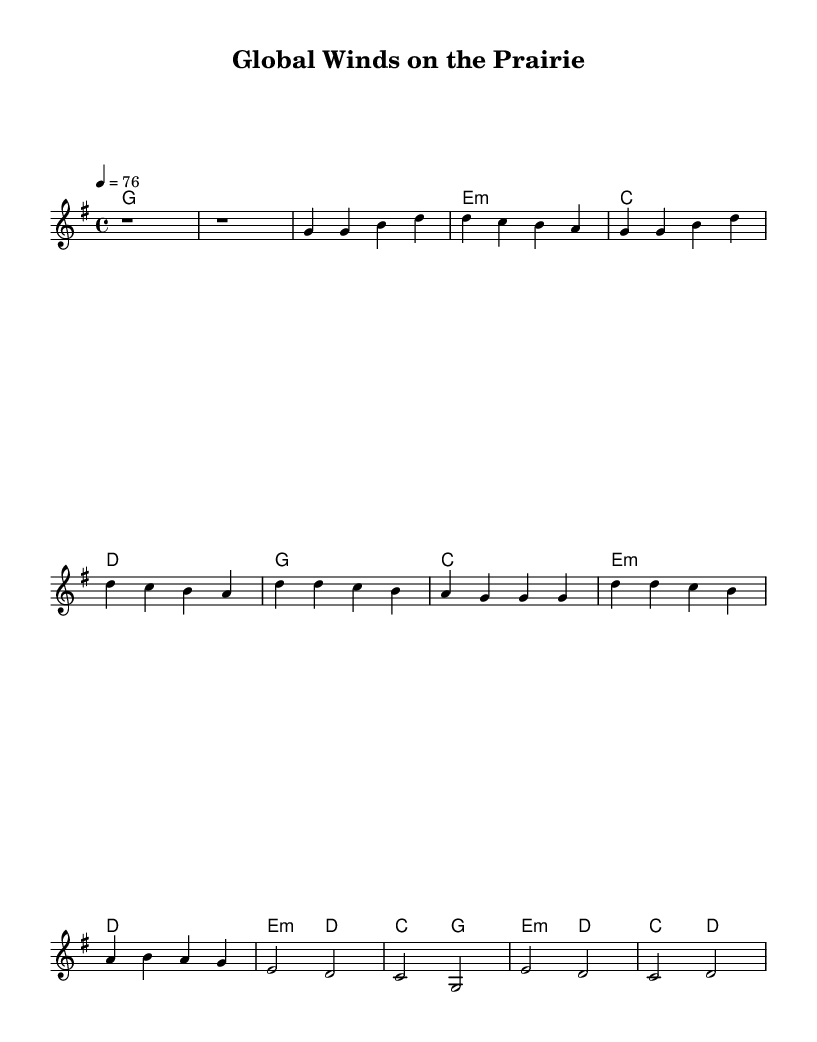What is the key signature of this music? The key signature indicates that the piece is in G major, which has one sharp. This can be identified from the beginning of the staff where the G major key signature is noted.
Answer: G major What is the time signature for this piece? The time signature is indicated at the beginning of the sheet music, showing four beats per measure. This is denoted by the "4/4" notation placed near the clef.
Answer: 4/4 What is the tempo marking for this song? The tempo marking is found at the beginning of the score, indicating how fast the piece should be played. In this case, it is set at 76 beats per minute.
Answer: 76 How many measures are there in the chorus section? By examining the chorus section, we can count the number of measures denoted by the bar lines. The chorus has four distinct measures.
Answer: 4 What type of chord follows the intro? The chord progression starts with a G major chord after the intro, which is evident from the chord names provided above the melody.
Answer: G major Why does the bridge use different chords compared to the verses? The bridge introduces new harmonic material, indicating a shift in the song's emotional or musical content. By analyzing the chords, we see that the bridge explores minor chords to create contrast with the verse's brighter major chords.
Answer: Different emotional content What musical elements are characteristic of Country Rock in this piece? This piece employs a simple yet emotional melody combined with traditional chord progressions typical of country rock, along with relatable lyrics focusing on rural themes and globalization's effects.
Answer: Simple melody and traditional chords 